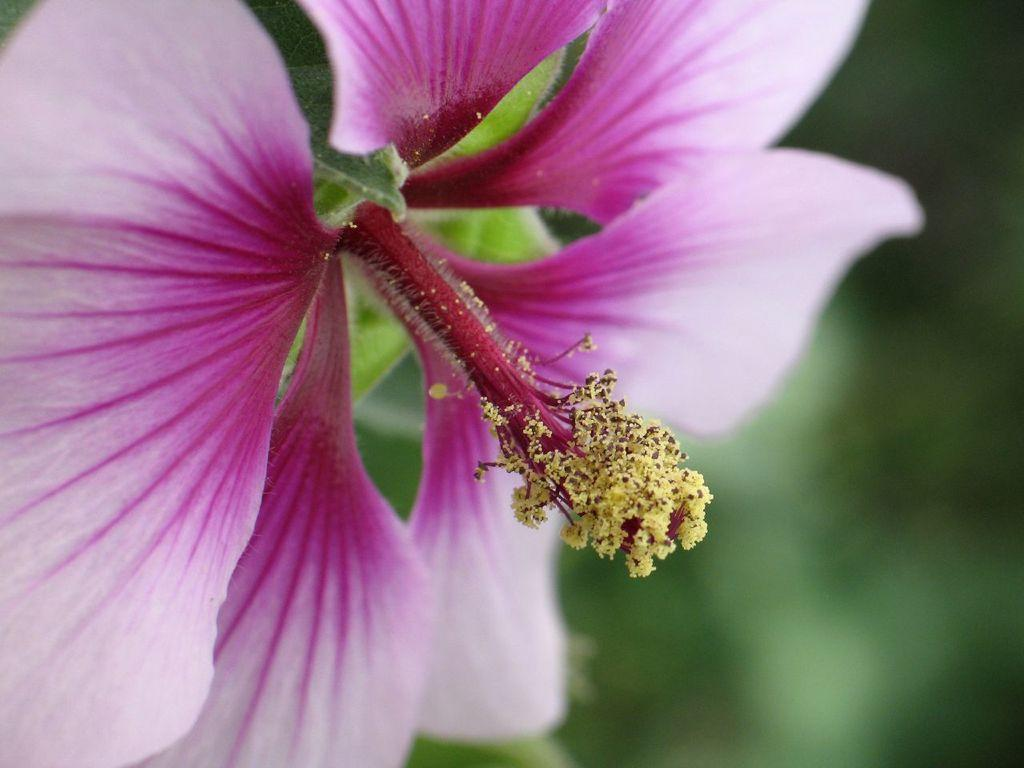What type of flower is in the image? There is a pink flower in the image. How would you describe the quality of the image's background? The image is blurry in the background. What color is predominant in the background of the image? The background has a green color. Can you see a cart carrying the beetle in the image? There is no cart or beetle present in the image. What type of brush is used to paint the background of the image? The image is a photograph, not a painting, so there is no brush used to create the background. 